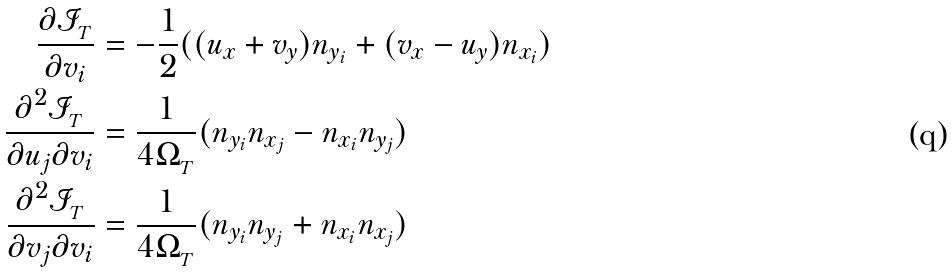<formula> <loc_0><loc_0><loc_500><loc_500>\frac { \partial \mathcal { I } _ { _ { T } } } { \partial v _ { i } } & = - \frac { 1 } { 2 } ( ( u _ { x } + v _ { y } ) n _ { y _ { i } } + ( v _ { x } - u _ { y } ) n _ { x _ { i } } ) \\ \frac { \partial ^ { 2 } \mathcal { I } _ { _ { T } } } { \partial u _ { j } \partial v _ { i } } & = \frac { 1 } { 4 \Omega _ { _ { T } } } ( n _ { y _ { i } } n _ { x _ { j } } - n _ { x _ { i } } n _ { y _ { j } } ) \\ \frac { \partial ^ { 2 } \mathcal { I } _ { _ { T } } } { \partial v _ { j } \partial v _ { i } } & = \frac { 1 } { 4 \Omega _ { _ { T } } } ( n _ { y _ { i } } n _ { y _ { j } } + n _ { x _ { i } } n _ { x _ { j } } )</formula> 